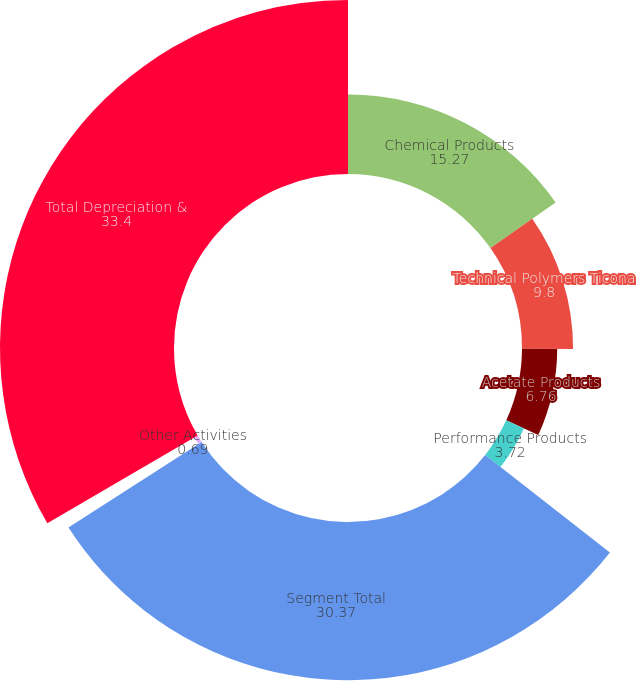<chart> <loc_0><loc_0><loc_500><loc_500><pie_chart><fcel>Chemical Products<fcel>Technical Polymers Ticona<fcel>Acetate Products<fcel>Performance Products<fcel>Segment Total<fcel>Other Activities<fcel>Total Depreciation &<nl><fcel>15.27%<fcel>9.8%<fcel>6.76%<fcel>3.72%<fcel>30.37%<fcel>0.69%<fcel>33.4%<nl></chart> 